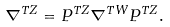<formula> <loc_0><loc_0><loc_500><loc_500>\nabla ^ { T Z } = P ^ { T Z } \nabla ^ { T W } P ^ { T Z } .</formula> 